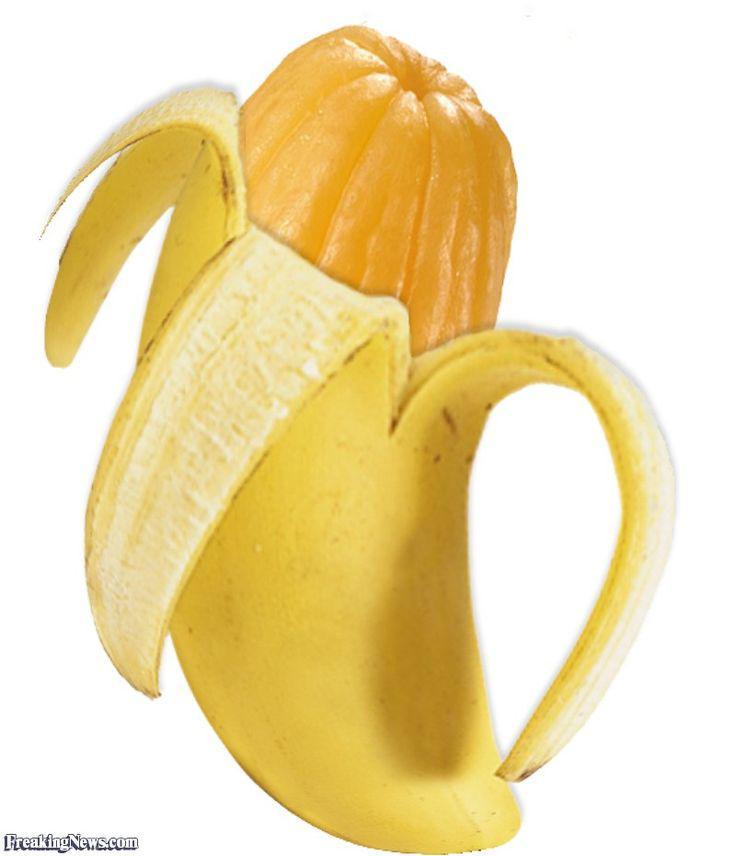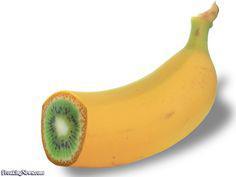The first image is the image on the left, the second image is the image on the right. Given the left and right images, does the statement "The combined images include a pink-fleshed banana and a banana peel that resembles a different type of fruit." hold true? Answer yes or no. No. 